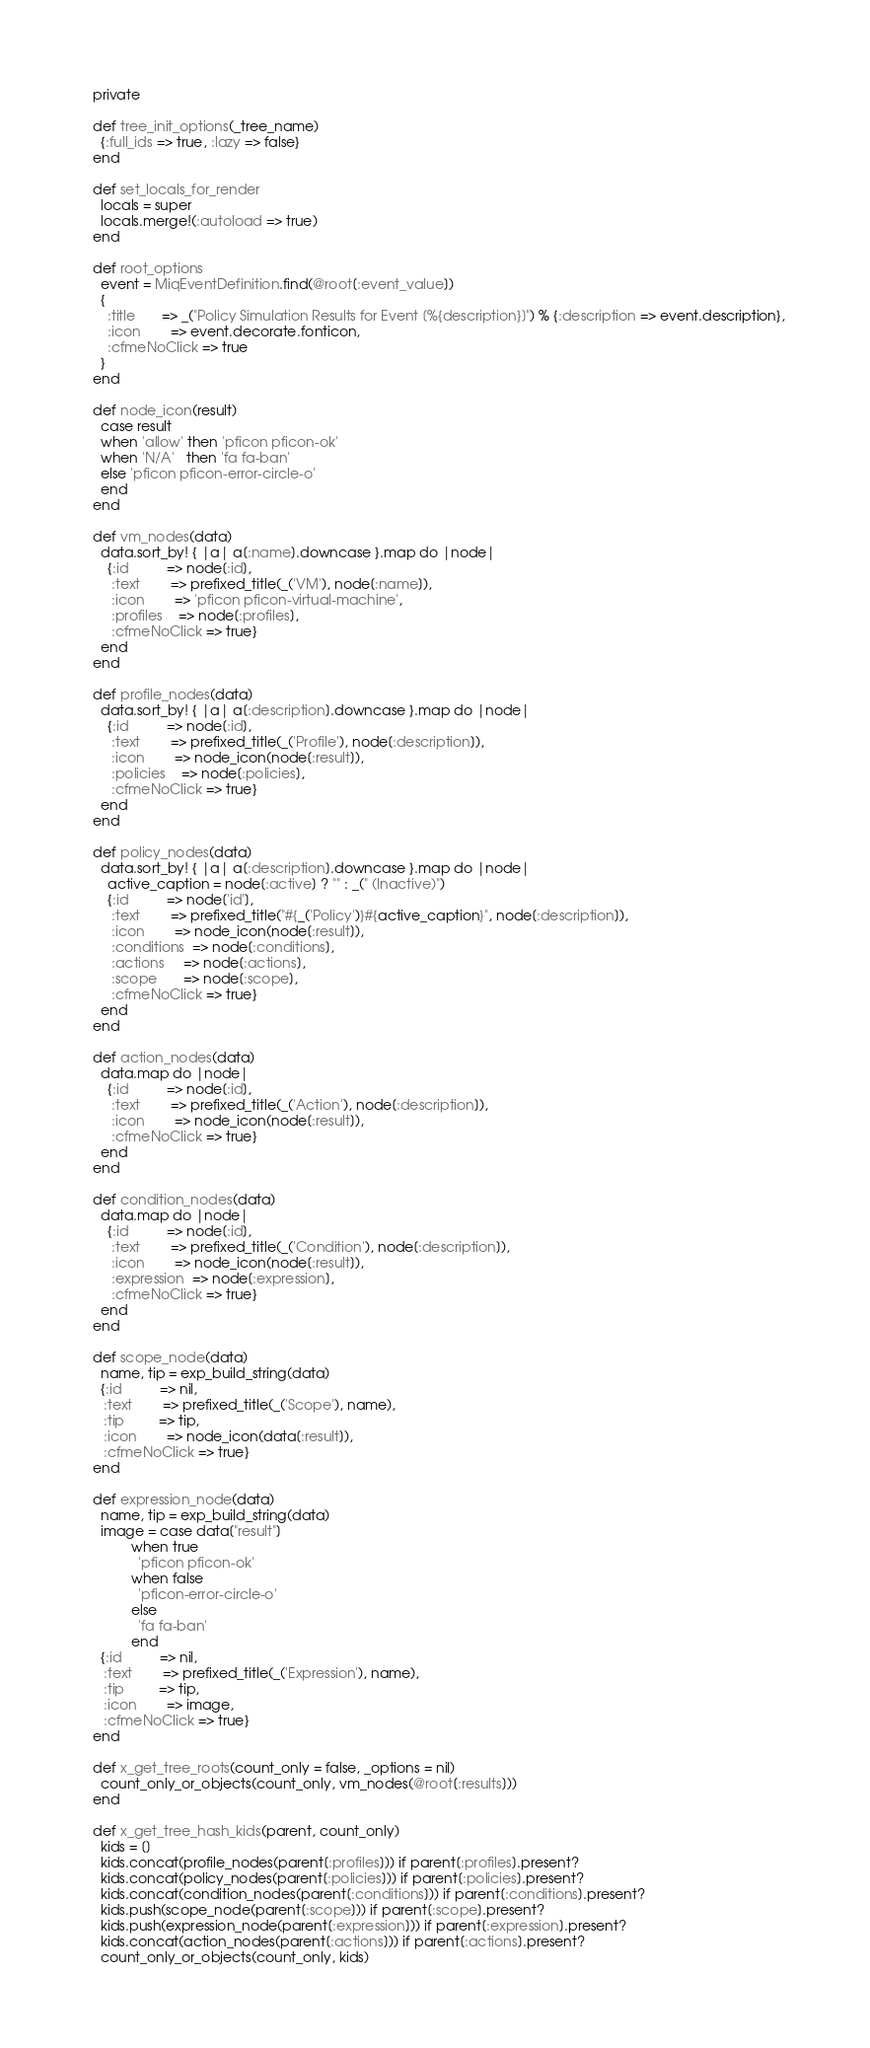<code> <loc_0><loc_0><loc_500><loc_500><_Ruby_>  private

  def tree_init_options(_tree_name)
    {:full_ids => true, :lazy => false}
  end

  def set_locals_for_render
    locals = super
    locals.merge!(:autoload => true)
  end

  def root_options
    event = MiqEventDefinition.find(@root[:event_value])
    {
      :title       => _("Policy Simulation Results for Event [%{description}]") % {:description => event.description},
      :icon        => event.decorate.fonticon,
      :cfmeNoClick => true
    }
  end

  def node_icon(result)
    case result
    when 'allow' then 'pficon pficon-ok'
    when 'N/A'   then 'fa fa-ban'
    else 'pficon pficon-error-circle-o'
    end
  end

  def vm_nodes(data)
    data.sort_by! { |a| a[:name].downcase }.map do |node|
      {:id          => node[:id],
       :text        => prefixed_title(_('VM'), node[:name]),
       :icon        => 'pficon pficon-virtual-machine',
       :profiles    => node[:profiles],
       :cfmeNoClick => true}
    end
  end

  def profile_nodes(data)
    data.sort_by! { |a| a[:description].downcase }.map do |node|
      {:id          => node[:id],
       :text        => prefixed_title(_('Profile'), node[:description]),
       :icon        => node_icon(node[:result]),
       :policies    => node[:policies],
       :cfmeNoClick => true}
    end
  end

  def policy_nodes(data)
    data.sort_by! { |a| a[:description].downcase }.map do |node|
      active_caption = node[:active] ? "" : _(" (Inactive)")
      {:id          => node['id'],
       :text        => prefixed_title("#{_('Policy')}#{active_caption}", node[:description]),
       :icon        => node_icon(node[:result]),
       :conditions  => node[:conditions],
       :actions     => node[:actions],
       :scope       => node[:scope],
       :cfmeNoClick => true}
    end
  end

  def action_nodes(data)
    data.map do |node|
      {:id          => node[:id],
       :text        => prefixed_title(_('Action'), node[:description]),
       :icon        => node_icon(node[:result]),
       :cfmeNoClick => true}
    end
  end

  def condition_nodes(data)
    data.map do |node|
      {:id          => node[:id],
       :text        => prefixed_title(_('Condition'), node[:description]),
       :icon        => node_icon(node[:result]),
       :expression  => node[:expression],
       :cfmeNoClick => true}
    end
  end

  def scope_node(data)
    name, tip = exp_build_string(data)
    {:id          => nil,
     :text        => prefixed_title(_('Scope'), name),
     :tip         => tip,
     :icon        => node_icon(data[:result]),
     :cfmeNoClick => true}
  end

  def expression_node(data)
    name, tip = exp_build_string(data)
    image = case data["result"]
            when true
              'pficon pficon-ok'
            when false
              'pficon-error-circle-o'
            else
              'fa fa-ban'
            end
    {:id          => nil,
     :text        => prefixed_title(_('Expression'), name),
     :tip         => tip,
     :icon        => image,
     :cfmeNoClick => true}
  end

  def x_get_tree_roots(count_only = false, _options = nil)
    count_only_or_objects(count_only, vm_nodes(@root[:results]))
  end

  def x_get_tree_hash_kids(parent, count_only)
    kids = []
    kids.concat(profile_nodes(parent[:profiles])) if parent[:profiles].present?
    kids.concat(policy_nodes(parent[:policies])) if parent[:policies].present?
    kids.concat(condition_nodes(parent[:conditions])) if parent[:conditions].present?
    kids.push(scope_node(parent[:scope])) if parent[:scope].present?
    kids.push(expression_node(parent[:expression])) if parent[:expression].present?
    kids.concat(action_nodes(parent[:actions])) if parent[:actions].present?
    count_only_or_objects(count_only, kids)</code> 